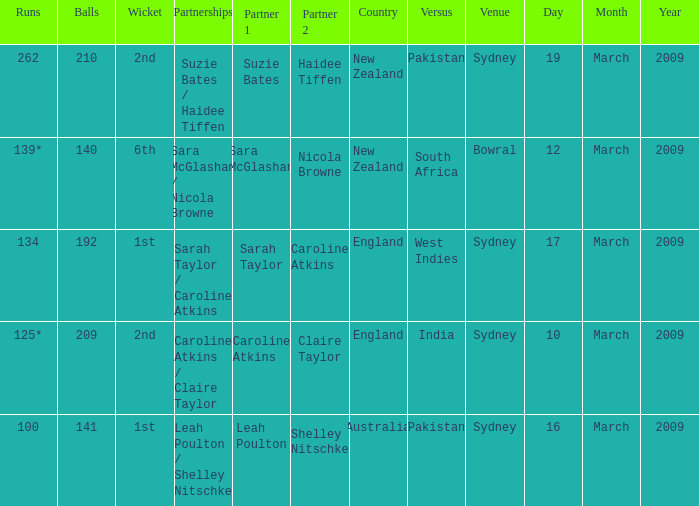What are the dates where the versus team is South Africa? 12 March 2009. 